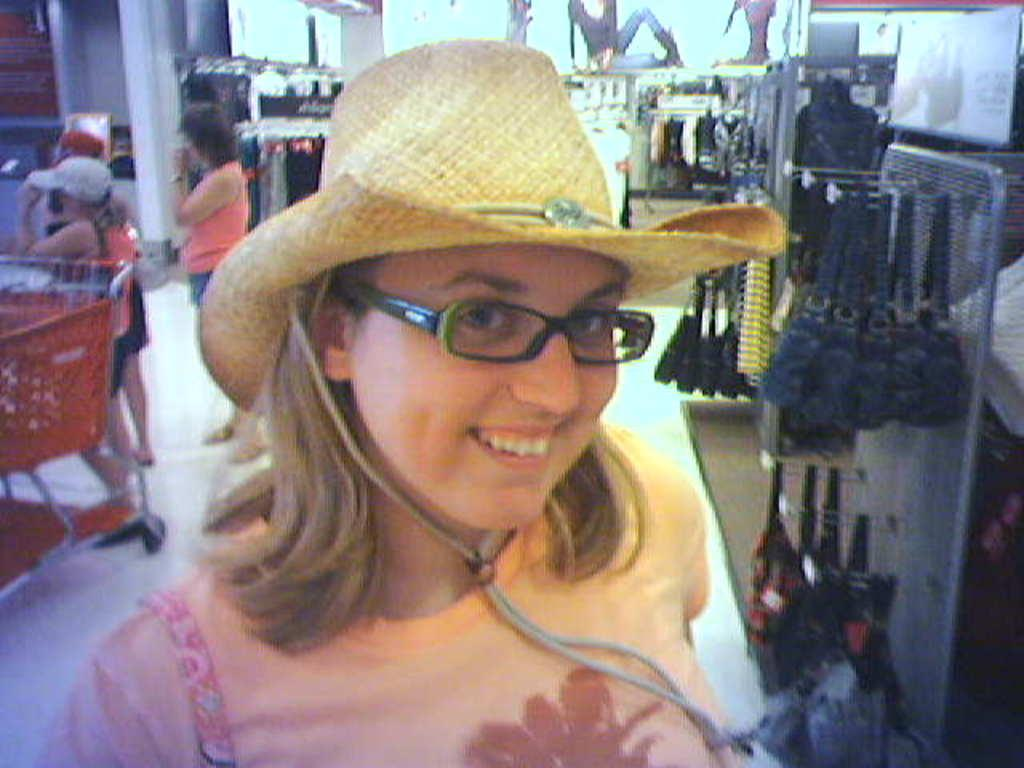Who is the main subject in the image? There is a woman in the image. What is the woman wearing on her head? The woman is wearing a hat. How many people are in the background of the image? There are three persons in the background of the image. What else can be seen in the background of the image besides the three persons? There are other objects in the background of the image. What type of van is parked next to the woman in the image? There is no van present in the image. What type of laborer can be seen working in the background of the image? There is no laborer present in the image. 